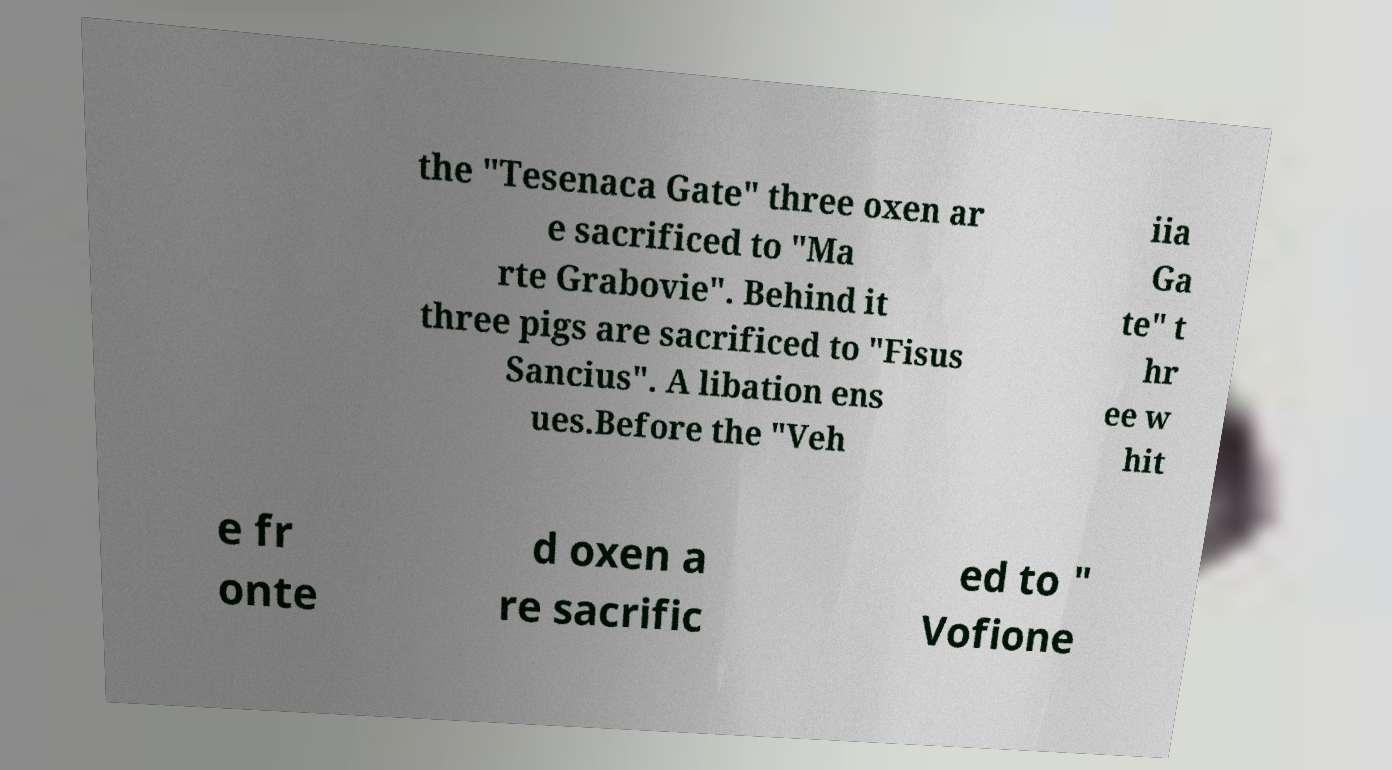For documentation purposes, I need the text within this image transcribed. Could you provide that? the "Tesenaca Gate" three oxen ar e sacrificed to "Ma rte Grabovie". Behind it three pigs are sacrificed to "Fisus Sancius". A libation ens ues.Before the "Veh iia Ga te" t hr ee w hit e fr onte d oxen a re sacrific ed to " Vofione 